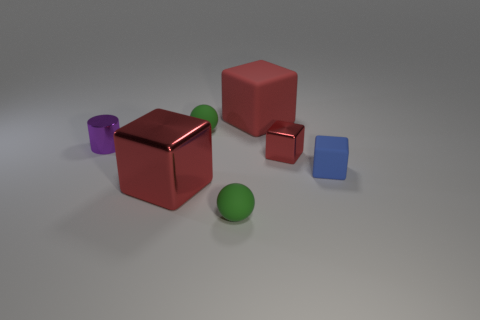Are there any other things that are made of the same material as the purple cylinder?
Keep it short and to the point. Yes. What is the color of the other large matte object that is the same shape as the blue rubber object?
Make the answer very short. Red. There is a green rubber thing behind the block that is on the left side of the large red block that is behind the large red shiny block; what is its shape?
Your response must be concise. Sphere. What size is the matte thing that is in front of the small red shiny thing and on the left side of the blue matte cube?
Offer a very short reply. Small. Is the number of small objects less than the number of big cylinders?
Ensure brevity in your answer.  No. There is a matte block that is behind the tiny cylinder; how big is it?
Offer a very short reply. Large. There is a tiny object that is both behind the blue rubber block and in front of the cylinder; what shape is it?
Your answer should be compact. Cube. What is the size of the other matte object that is the same shape as the red matte object?
Give a very brief answer. Small. How many red spheres have the same material as the tiny purple cylinder?
Offer a very short reply. 0. Do the big metallic block and the rubber object that is to the right of the small red shiny object have the same color?
Offer a very short reply. No. 